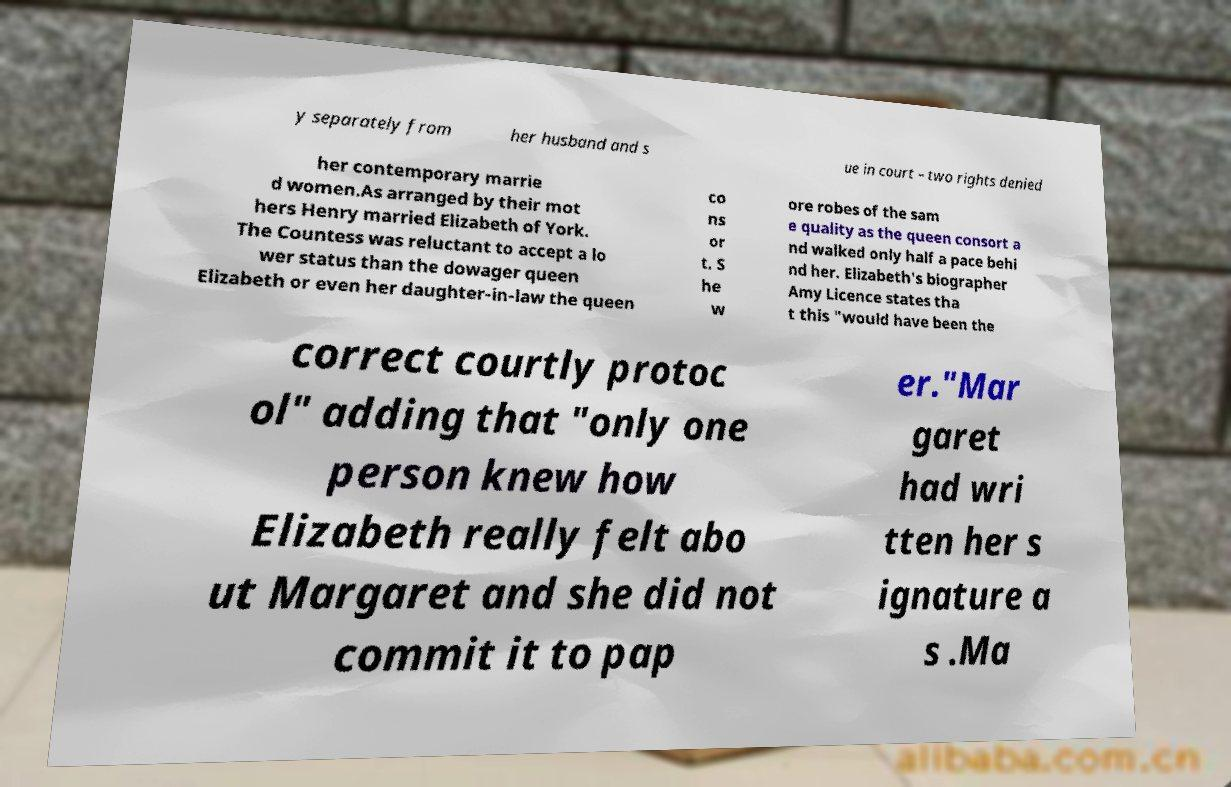Could you assist in decoding the text presented in this image and type it out clearly? y separately from her husband and s ue in court – two rights denied her contemporary marrie d women.As arranged by their mot hers Henry married Elizabeth of York. The Countess was reluctant to accept a lo wer status than the dowager queen Elizabeth or even her daughter-in-law the queen co ns or t. S he w ore robes of the sam e quality as the queen consort a nd walked only half a pace behi nd her. Elizabeth's biographer Amy Licence states tha t this "would have been the correct courtly protoc ol" adding that "only one person knew how Elizabeth really felt abo ut Margaret and she did not commit it to pap er."Mar garet had wri tten her s ignature a s .Ma 